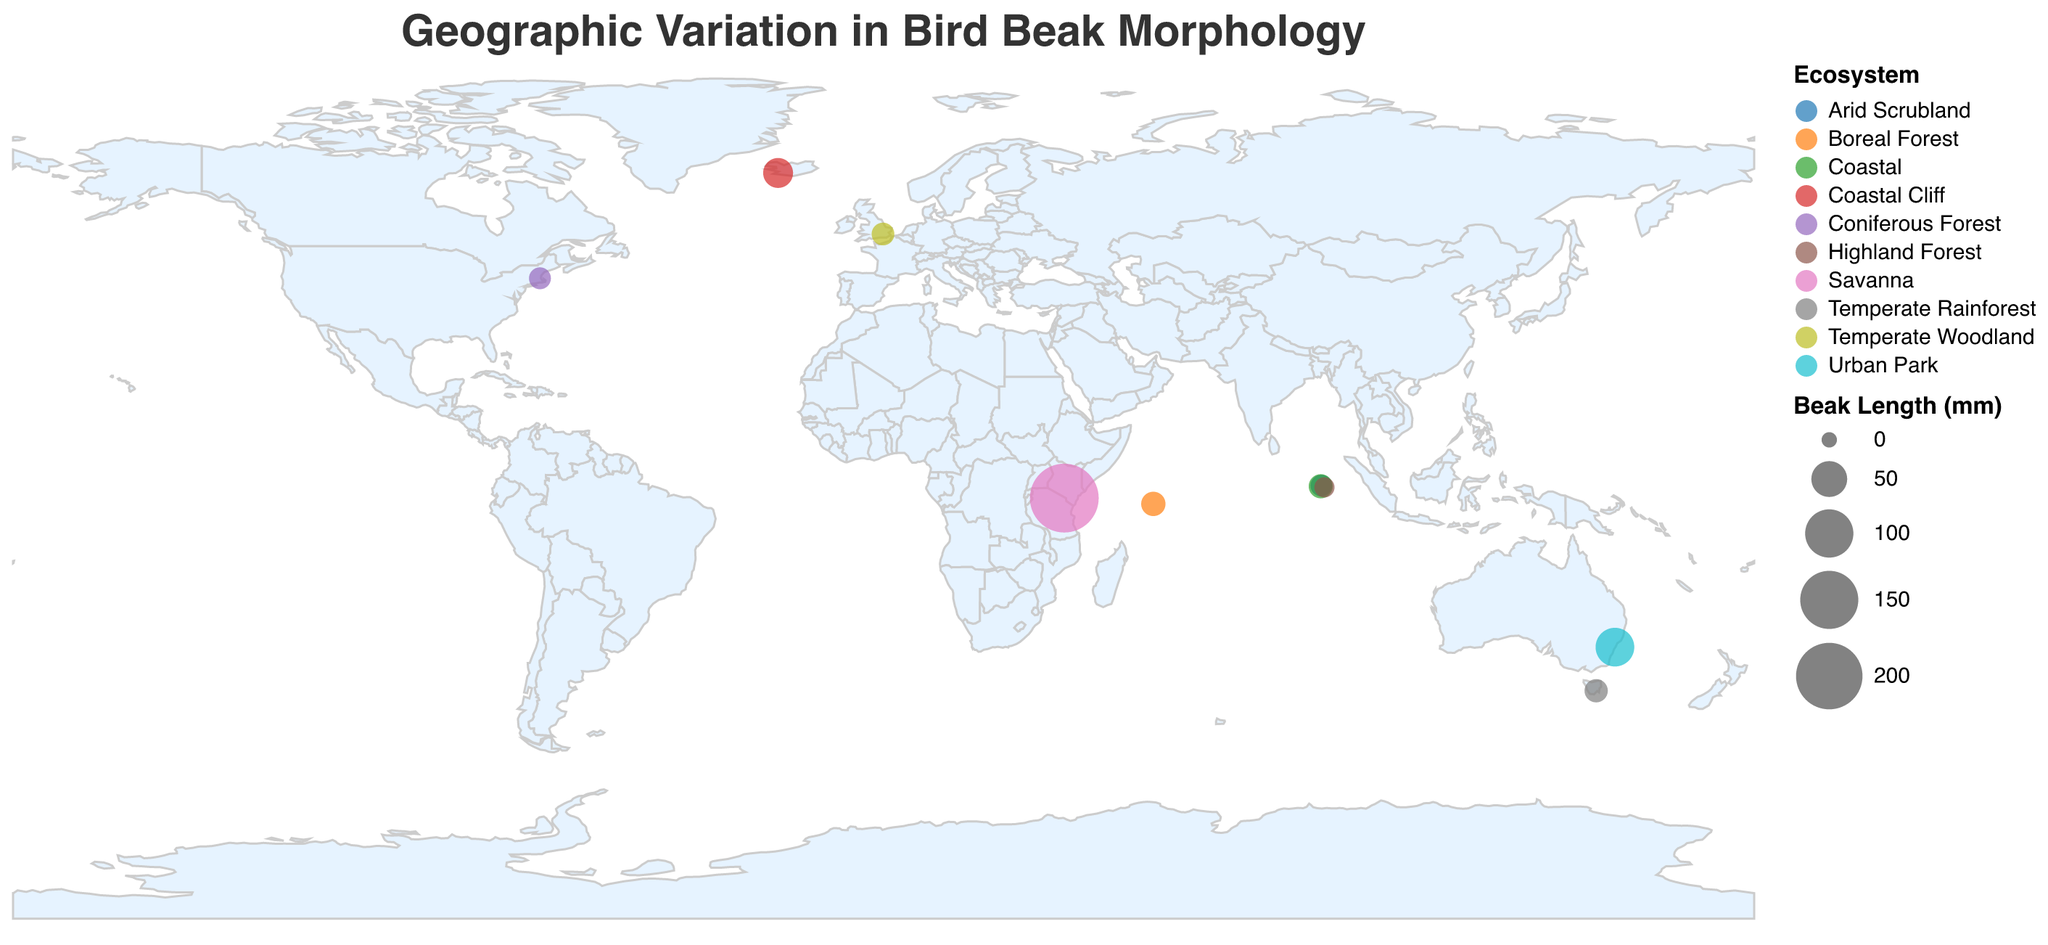What is the title of the figure? The title is located at the top of the figure and reads "Geographic Variation in Bird Beak Morphology".
Answer: Geographic Variation in Bird Beak Morphology How many bird species are represented in the figure? The data contains a total of 10 different bird species, each plotted on the figure.
Answer: 10 Which species has the largest beak length and in which ecosystem is it found? The data point with the largest size on the figure represents the species Bucorvus leadbeateri, and it is in the Savanna ecosystem, as indicated by the tooltip information.
Answer: Bucorvus leadbeateri, Savanna Compare the beak lengths of Fratercula arctica and Geospiza magnirostris. Which one is longer and by how much? According to the tooltip information, Fratercula arctica has a beak length of 31.5 mm, while Geospiza magnirostris has a beak length of 16.7 mm. The difference is 31.5 - 16.7 = 14.8 mm.
Answer: Fratercula arctica, 14.8 mm What are the three smallest beak lengths and which species do they belong to? Reviewing the size of the data points, the three smallest beak lengths are for Geospiza fuliginosa (8.3 mm), Sitta canadensis (11.8 mm), and Geospiza fortis (11.2 mm).
Answer: Geospiza fuliginosa, Sitta canadensis, Geospiza fortis Which ecosystems are represented by the color scheme and list of bird species? Each color in the figure corresponds to a different ecosystem as shown in the legend. The ecosystems and their respective bird species are: Arid Scrubland - Geospiza fortis, Coastal - Geospiza magnirostris, Highland Forest - Geospiza fuliginosa, Temperate Woodland - Certhia familiaris, Coniferous Forest - Sitta canadensis, Urban Park - Dacelo novaeguineae, Savanna - Bucorvus leadbeateri, Boreal Forest - Loxia leucoptera, Coastal Cliff - Fratercula arctica, Temperate Rainforest - Pachycephala pectoralis.
Answer: Arid Scrubland, Coastal, Highland Forest, Temperate Woodland, Coniferous Forest, Urban Park, Savanna, Boreal Forest, Coastal Cliff, Temperate Rainforest What is the ecosystem of the bird species with the highest beak depth? The species Bucorvus leadbeateri has the highest beak depth of 75.6 mm, found in the Savanna ecosystem, as shown in the tooltip information.
Answer: Savanna How do the beak widths of Certhia familiaris and Pachycephala pectoralis compare? Certhia familiaris has a beak width of 4.1 mm, while Pachycephala pectoralis has a beak width of 7.5 mm, according to the tooltip information. The difference is 7.5 - 4.1 = 3.4 mm.
Answer: Pachycephala pectoralis, 3.4 mm What is the average beak depth of all species in forest ecosystems (Highland, Temperate Woodland, Coniferous, Boreal, and Temperate Rainforest)? The beak depths in the forest ecosystems are: Highland Forest (7.1), Temperate Woodland (3.2), Coniferous Forest (4.5), Boreal Forest (10.9), and Temperate Rainforest (6.8). Summing these gives 7.1 + 3.2 + 4.5 + 10.9 + 6.8 = 32.5, and the average is 32.5 / 5 = 6.5.
Answer: 6.5 mm Which species is associated with Temperate Rainforest, and what is its beak morphology in terms of length, depth, and width? The tooltip shows that Pachycephala pectoralis is the species found in the Temperate Rainforest, with a beak length of 14.7 mm, beak depth of 6.8 mm, and beak width of 7.5 mm.
Answer: Pachycephala pectoralis, 14.7 mm (length), 6.8 mm (depth), 7.5 mm (width) 